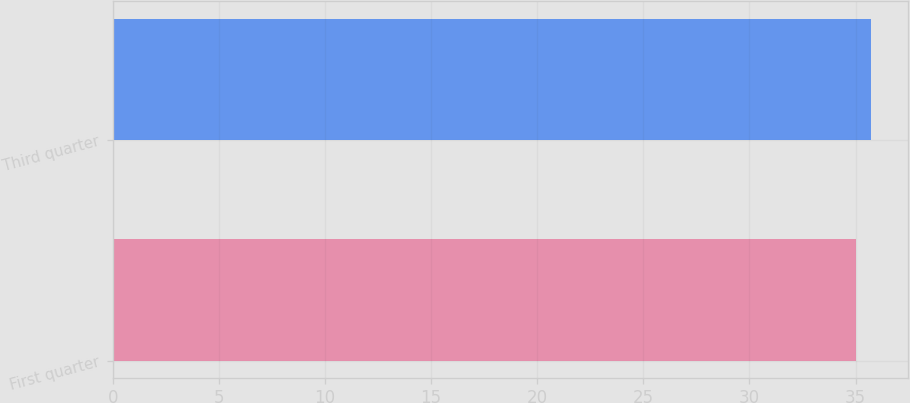<chart> <loc_0><loc_0><loc_500><loc_500><bar_chart><fcel>First quarter<fcel>Third quarter<nl><fcel>35.01<fcel>35.71<nl></chart> 